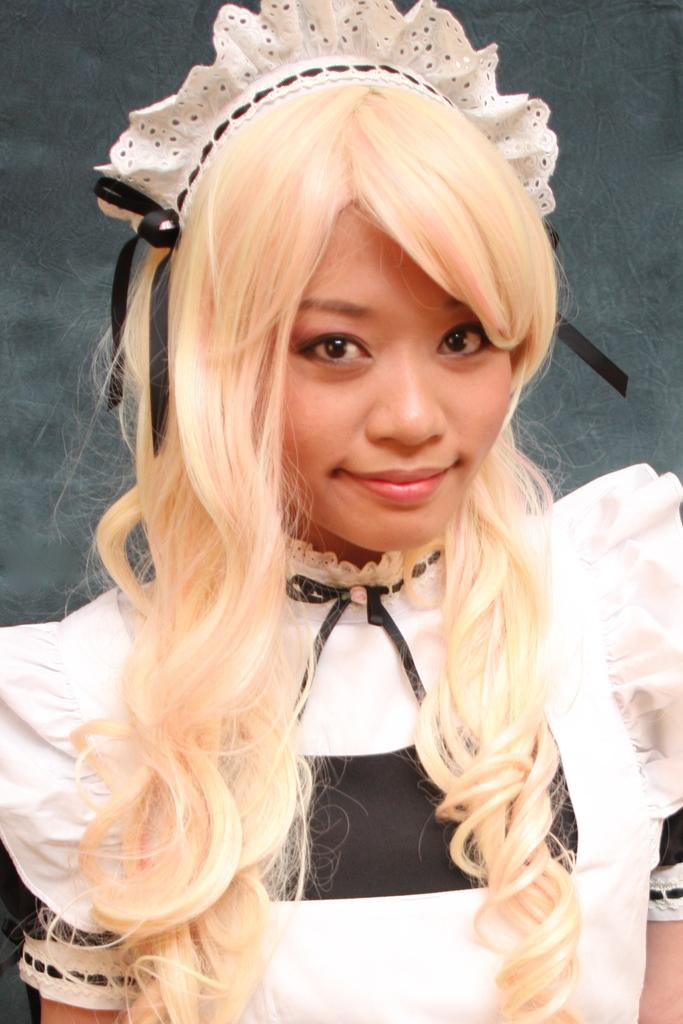Who is in the image? There is a girl in the image. What is the girl doing in the image? The girl is smiling in the image. What can be seen behind the girl? There is a wall behind the girl. What type of paper is the girl using to support her learning in the image? There is no paper or learning activity present in the image; it simply shows a girl smiling. 